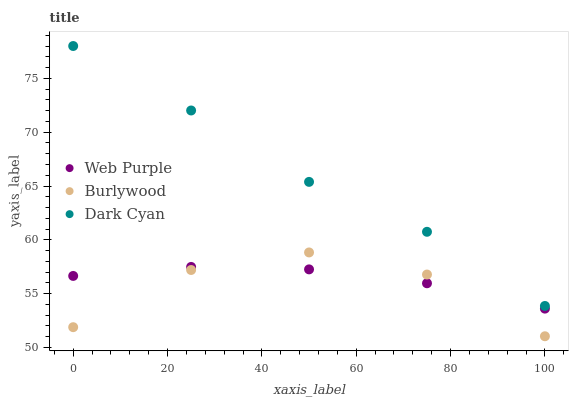Does Burlywood have the minimum area under the curve?
Answer yes or no. Yes. Does Dark Cyan have the maximum area under the curve?
Answer yes or no. Yes. Does Web Purple have the minimum area under the curve?
Answer yes or no. No. Does Web Purple have the maximum area under the curve?
Answer yes or no. No. Is Web Purple the smoothest?
Answer yes or no. Yes. Is Burlywood the roughest?
Answer yes or no. Yes. Is Dark Cyan the smoothest?
Answer yes or no. No. Is Dark Cyan the roughest?
Answer yes or no. No. Does Burlywood have the lowest value?
Answer yes or no. Yes. Does Web Purple have the lowest value?
Answer yes or no. No. Does Dark Cyan have the highest value?
Answer yes or no. Yes. Does Web Purple have the highest value?
Answer yes or no. No. Is Burlywood less than Dark Cyan?
Answer yes or no. Yes. Is Dark Cyan greater than Web Purple?
Answer yes or no. Yes. Does Burlywood intersect Web Purple?
Answer yes or no. Yes. Is Burlywood less than Web Purple?
Answer yes or no. No. Is Burlywood greater than Web Purple?
Answer yes or no. No. Does Burlywood intersect Dark Cyan?
Answer yes or no. No. 